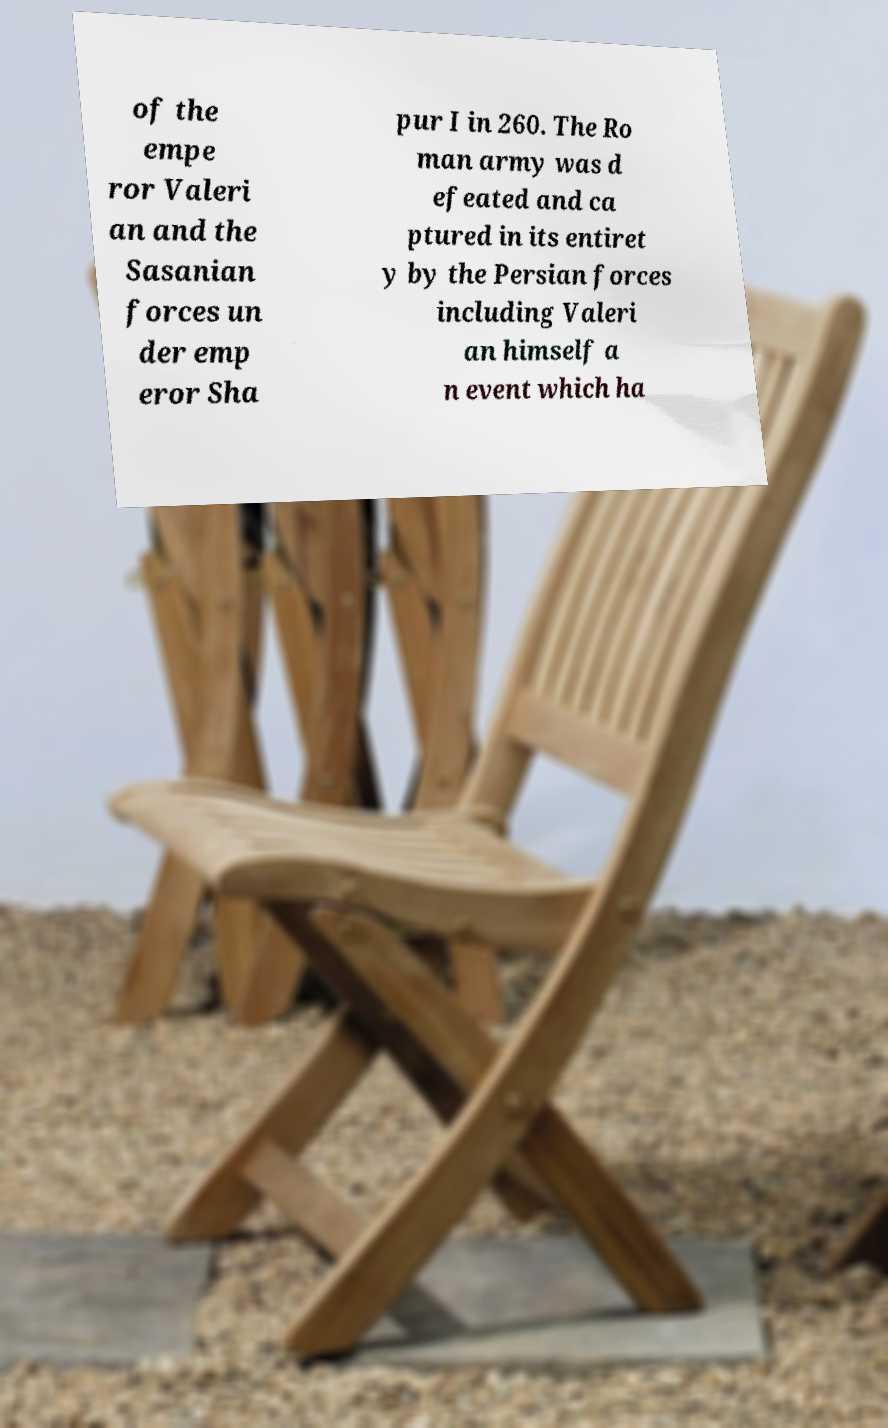Can you accurately transcribe the text from the provided image for me? of the empe ror Valeri an and the Sasanian forces un der emp eror Sha pur I in 260. The Ro man army was d efeated and ca ptured in its entiret y by the Persian forces including Valeri an himself a n event which ha 